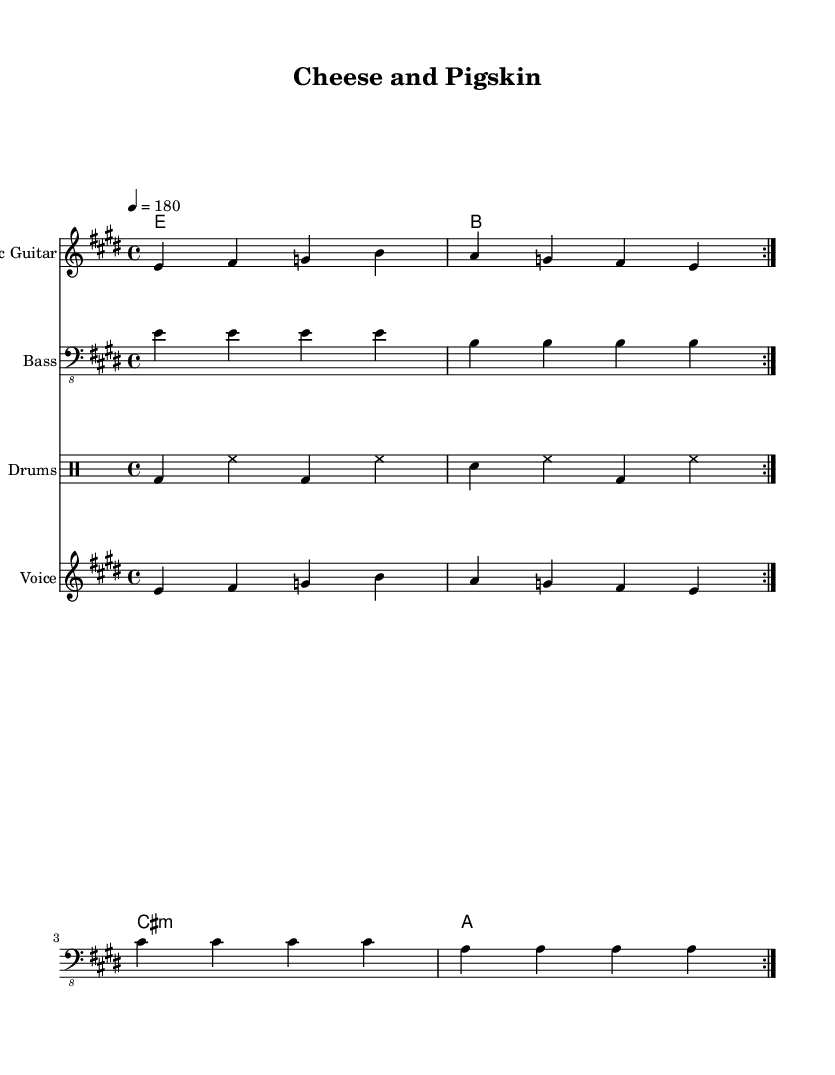What is the key signature of this music? The key signature indicated at the beginning of the sheet music shows two sharps, which corresponds to the key of E major.
Answer: E major What is the time signature of this music? The time signature is located at the beginning of the score. It is written as a fraction with a 4 on top and a 4 on the bottom, indicating that there are four beats in a measure.
Answer: 4/4 What is the tempo marking for this piece? The tempo is indicated in beats per minute and is denoted as "4 = 180," which means there are 180 beats in a minute at the quarter note speed.
Answer: 180 How many measures are repeated in the sections? The repeat sign in the music indicates that a specific section is played twice. This is observed by counting the repeat markings within the provided sections, each indicating to play the measures again.
Answer: 2 What chords are used in the song? The chord names are located at the top of the chord staff and are listed as E, B, C sharp minor, and A, representing the harmonies accompanying the music.
Answer: E, B, C sharp minor, A What instrument plays the voice part? The voice part is clearly labeled in the sheet, indicating it is meant for a singer. The staff dedicated to the voice is marked accordingly within the score.
Answer: Voice What is the general theme reflected in the lyrics? The lyrics' content revolves around Friday nights and local pride, suggesting a celebration connected to sports culture. The phrase "Cheesehead pride" gives a regional identity related to Wisconsin sports culture.
Answer: Sports culture 